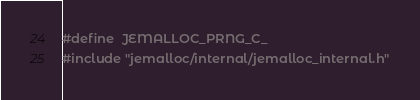Convert code to text. <code><loc_0><loc_0><loc_500><loc_500><_C_>#define	JEMALLOC_PRNG_C_
#include "jemalloc/internal/jemalloc_internal.h"
</code> 